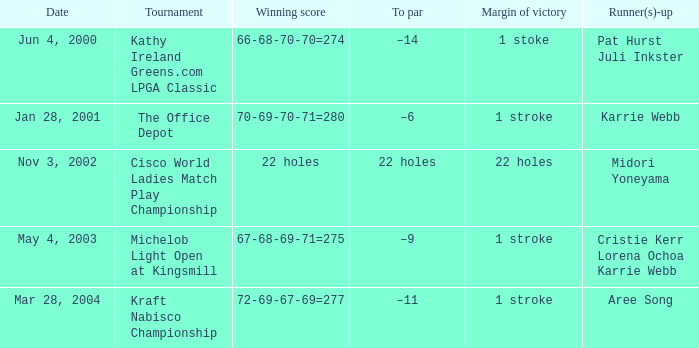Where was the tournament dated nov 3, 2002? Cisco World Ladies Match Play Championship. 